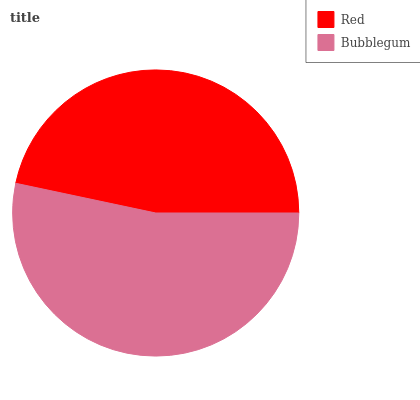Is Red the minimum?
Answer yes or no. Yes. Is Bubblegum the maximum?
Answer yes or no. Yes. Is Bubblegum the minimum?
Answer yes or no. No. Is Bubblegum greater than Red?
Answer yes or no. Yes. Is Red less than Bubblegum?
Answer yes or no. Yes. Is Red greater than Bubblegum?
Answer yes or no. No. Is Bubblegum less than Red?
Answer yes or no. No. Is Bubblegum the high median?
Answer yes or no. Yes. Is Red the low median?
Answer yes or no. Yes. Is Red the high median?
Answer yes or no. No. Is Bubblegum the low median?
Answer yes or no. No. 